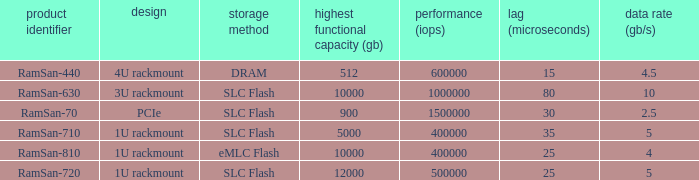Specify the range distortion for the ramsan-63 3U rackmount. 